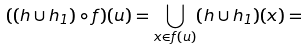<formula> <loc_0><loc_0><loc_500><loc_500>( ( h \cup h _ { 1 } ) \circ f ) ( u ) = \underset { x \in f ( u ) } { \bigcup } ( h \cup h _ { 1 } ) ( x ) =</formula> 